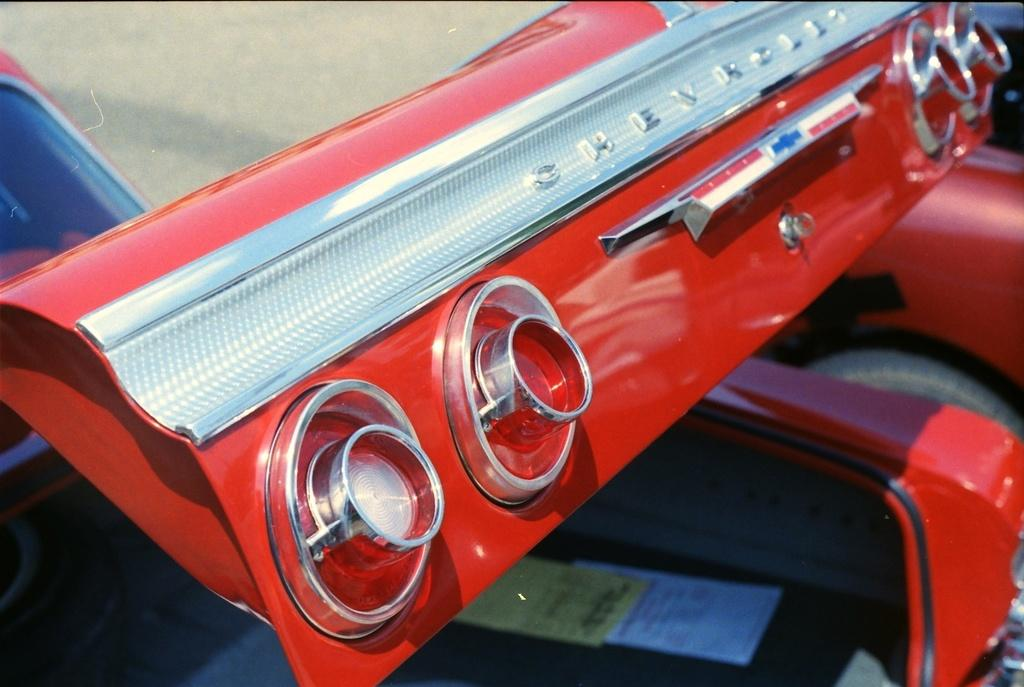What type of vehicle is partially visible in the image? A part of a car is visible in the image. How many lights are on the car? There are four lights on the car. What is placed inside the car? Papers are placed in the car. What is the color of the car? The car is red in color. What type of game is being played inside the car? There is no indication of a game being played inside the car in the image. 